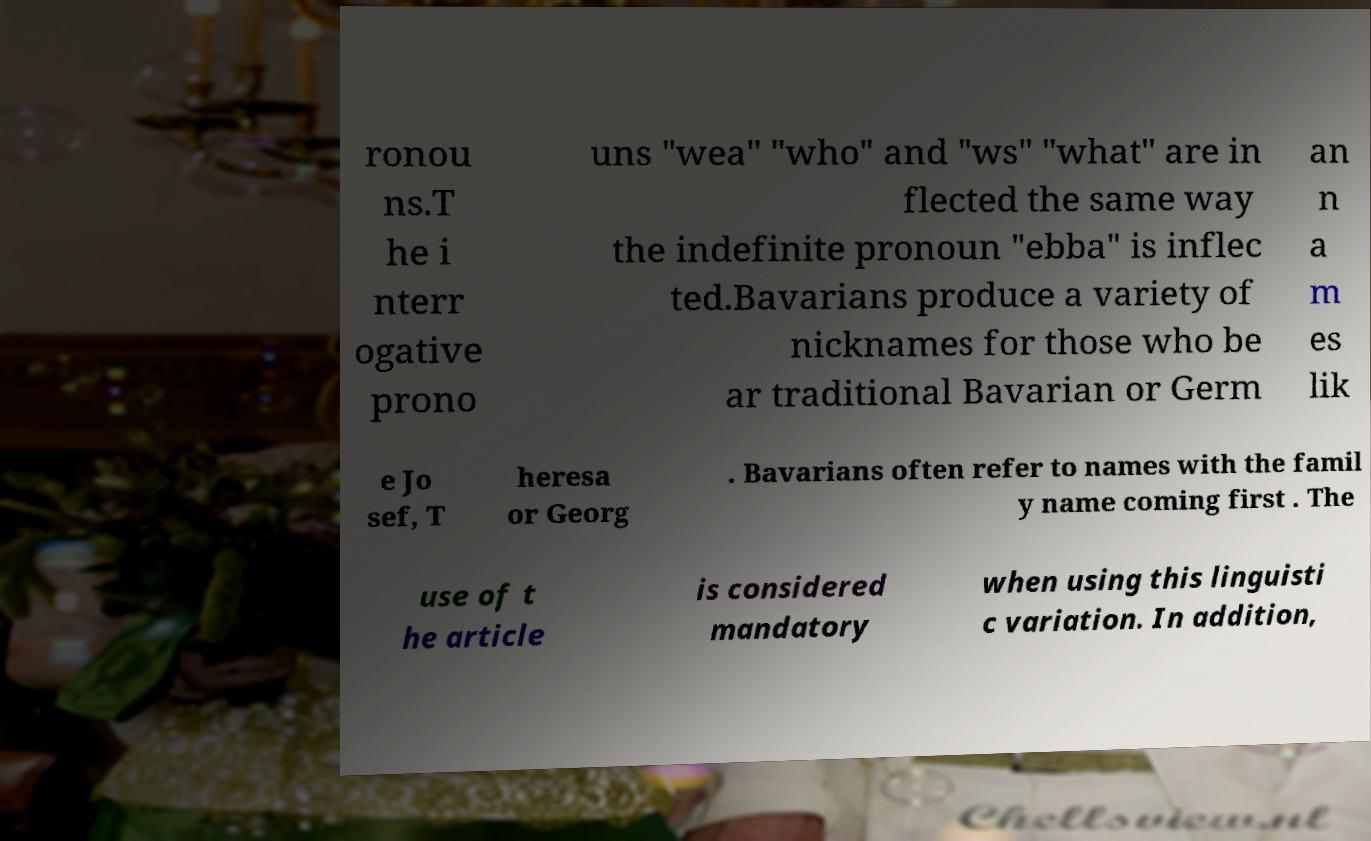Could you extract and type out the text from this image? ronou ns.T he i nterr ogative prono uns "wea" "who" and "ws" "what" are in flected the same way the indefinite pronoun "ebba" is inflec ted.Bavarians produce a variety of nicknames for those who be ar traditional Bavarian or Germ an n a m es lik e Jo sef, T heresa or Georg . Bavarians often refer to names with the famil y name coming first . The use of t he article is considered mandatory when using this linguisti c variation. In addition, 